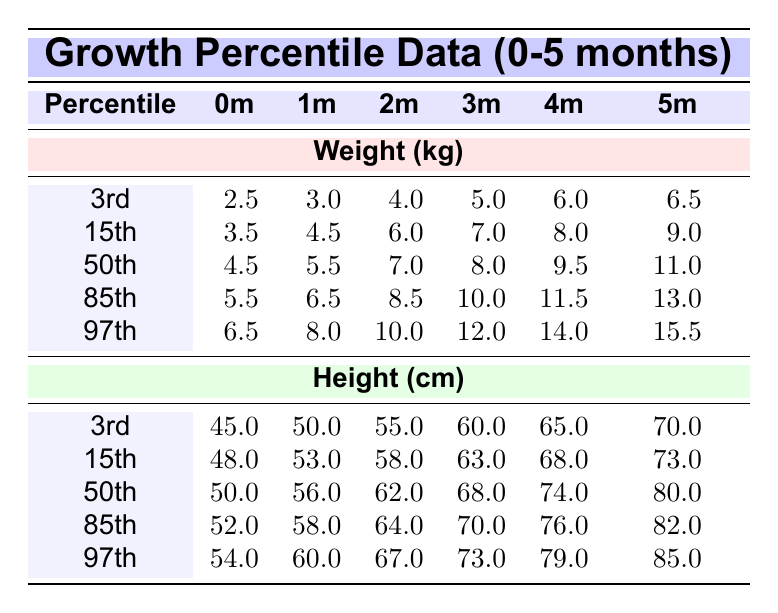What is the weight at the 50th percentile for a 4-month-old? The table shows that under the weight section, the 50th percentile for the 4-month-old is 9.5 kg.
Answer: 9.5 kg What is the height of a child at the 85th percentile for 2 months? Referring to the height section of the table, the 85th percentile for a 2-month-old is 64.0 cm.
Answer: 64.0 cm Is the weight of a 5-month-old at the 3rd percentile greater than 6.0 kg? The table shows that the weight at the 3rd percentile for a 5-month-old is 6.5 kg, which is greater than 6.0 kg.
Answer: Yes What is the difference in weight between the 15th percentile and the 85th percentile for a 1-month-old? For 1 month, the 15th percentile weight is 4.5 kg and the 85th percentile weight is 6.5 kg. The difference is 6.5 kg - 4.5 kg = 2.0 kg.
Answer: 2.0 kg What is the median height for a 3-month-old? The median, or 50th percentile, height for a 3-month-old is found in the height section of the table, which is 68.0 cm.
Answer: 68.0 cm At what age does the weight at the 97th percentile first exceed 14.0 kg? Looking at the weight at the 97th percentile, it goes above 14.0 kg at the age of 4 months (14.0 kg) and 5 months (15.5 kg).
Answer: 4 months What percentiles have a weight of 8.0 kg for a 4-month-old? Referring to the weight data for a 4-month-old, we see that 8.0 kg corresponds to the 15th percentile and does not exceed 9.5 kg at the 50th percentile.
Answer: 15th percentile What is the average height for infants at the 3rd percentile across all months? The average height can be calculated by summing the heights at the 3rd percentile for all months: (45.0 + 50.0 + 55.0 + 60.0 + 65.0 + 70.0) / 6 = 57.5 cm.
Answer: 57.5 cm 